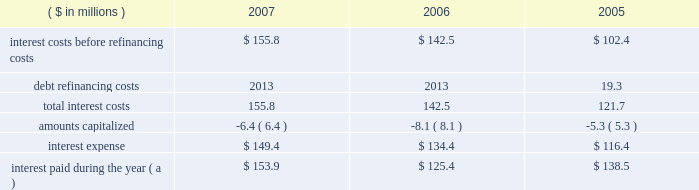Page 59 of 94 notes to consolidated financial statements ball corporation and subsidiaries 13 .
Debt and interest costs ( continued ) long-term debt obligations outstanding at december 31 , 2007 , have maturities of $ 127.1 million , $ 160 million , $ 388.4 million , $ 625.1 million and $ 550.3 million for the years ending december 31 , 2008 through 2012 , respectively , and $ 456.1 million thereafter .
Ball provides letters of credit in the ordinary course of business to secure liabilities recorded in connection with industrial development revenue bonds and certain self-insurance arrangements .
Letters of credit outstanding at december 31 , 2007 and 2006 , were $ 41 million and $ 52.4 million , respectively .
The notes payable and senior credit facilities are guaranteed on a full , unconditional and joint and several basis by certain of the company 2019s domestic wholly owned subsidiaries .
Certain foreign denominated tranches of the senior credit facilities are similarly guaranteed by certain of the company 2019s wholly owned foreign subsidiaries .
Note 22 contains further details as well as condensed , consolidating financial information for the company , segregating the guarantor subsidiaries and non-guarantor subsidiaries .
The company was not in default of any loan agreement at december 31 , 2007 , and has met all debt payment obligations .
The u.s .
Note agreements , bank credit agreement and industrial development revenue bond agreements contain certain restrictions relating to dividend payments , share repurchases , investments , financial ratios , guarantees and the incurrence of additional indebtedness .
On march 27 , 2006 , ball expanded its senior secured credit facilities with the addition of a $ 500 million term d loan facility due in installments through october 2011 .
Also on march 27 , 2006 , ball issued at a price of 99.799 percent $ 450 million of 6.625% ( 6.625 % ) senior notes ( effective yield to maturity of 6.65 percent ) due in march 2018 .
The proceeds from these financings were used to refinance existing u.s .
Can debt with ball corporation debt at lower interest rates , acquire certain north american plastic container net assets from alcan and reduce seasonal working capital debt .
( see note 3 for further details of the acquisitions. ) on october 13 , 2005 , ball refinanced its senior secured credit facilities to extend debt maturities at lower interest rate spreads and provide the company with additional borrowing capacity for future growth .
During the third and fourth quarters of 2005 , ball redeemed its 7.75% ( 7.75 % ) senior notes due in august 2006 .
The refinancing and senior note redemptions resulted in a debt refinancing charge of $ 19.3 million ( $ 12.3 million after tax ) for the related call premium and unamortized debt issuance costs .
A summary of total interest cost paid and accrued follows: .
( a ) includes $ 6.6 million paid in 2005 in connection with the redemption of the company 2019s senior and senior subordinated notes. .
What is the percentage change in interest expense from 2005 to 2006? 
Computations: ((134.4 - 116.4) / 116.4)
Answer: 0.15464. 